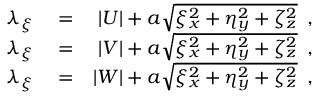<formula> <loc_0><loc_0><loc_500><loc_500>\begin{array} { r l r } { \lambda _ { \xi } } & = } & { | U | + a \sqrt { \xi _ { x } ^ { 2 } + \eta _ { y } ^ { 2 } + \zeta _ { z } ^ { 2 } } \, , } \\ { \lambda _ { \xi } } & = } & { | V | + a \sqrt { \xi _ { x } ^ { 2 } + \eta _ { y } ^ { 2 } + \zeta _ { z } ^ { 2 } } \, , } \\ { \lambda _ { \xi } } & = } & { | W | + a \sqrt { \xi _ { x } ^ { 2 } + \eta _ { y } ^ { 2 } + \zeta _ { z } ^ { 2 } } \, , } \end{array}</formula> 